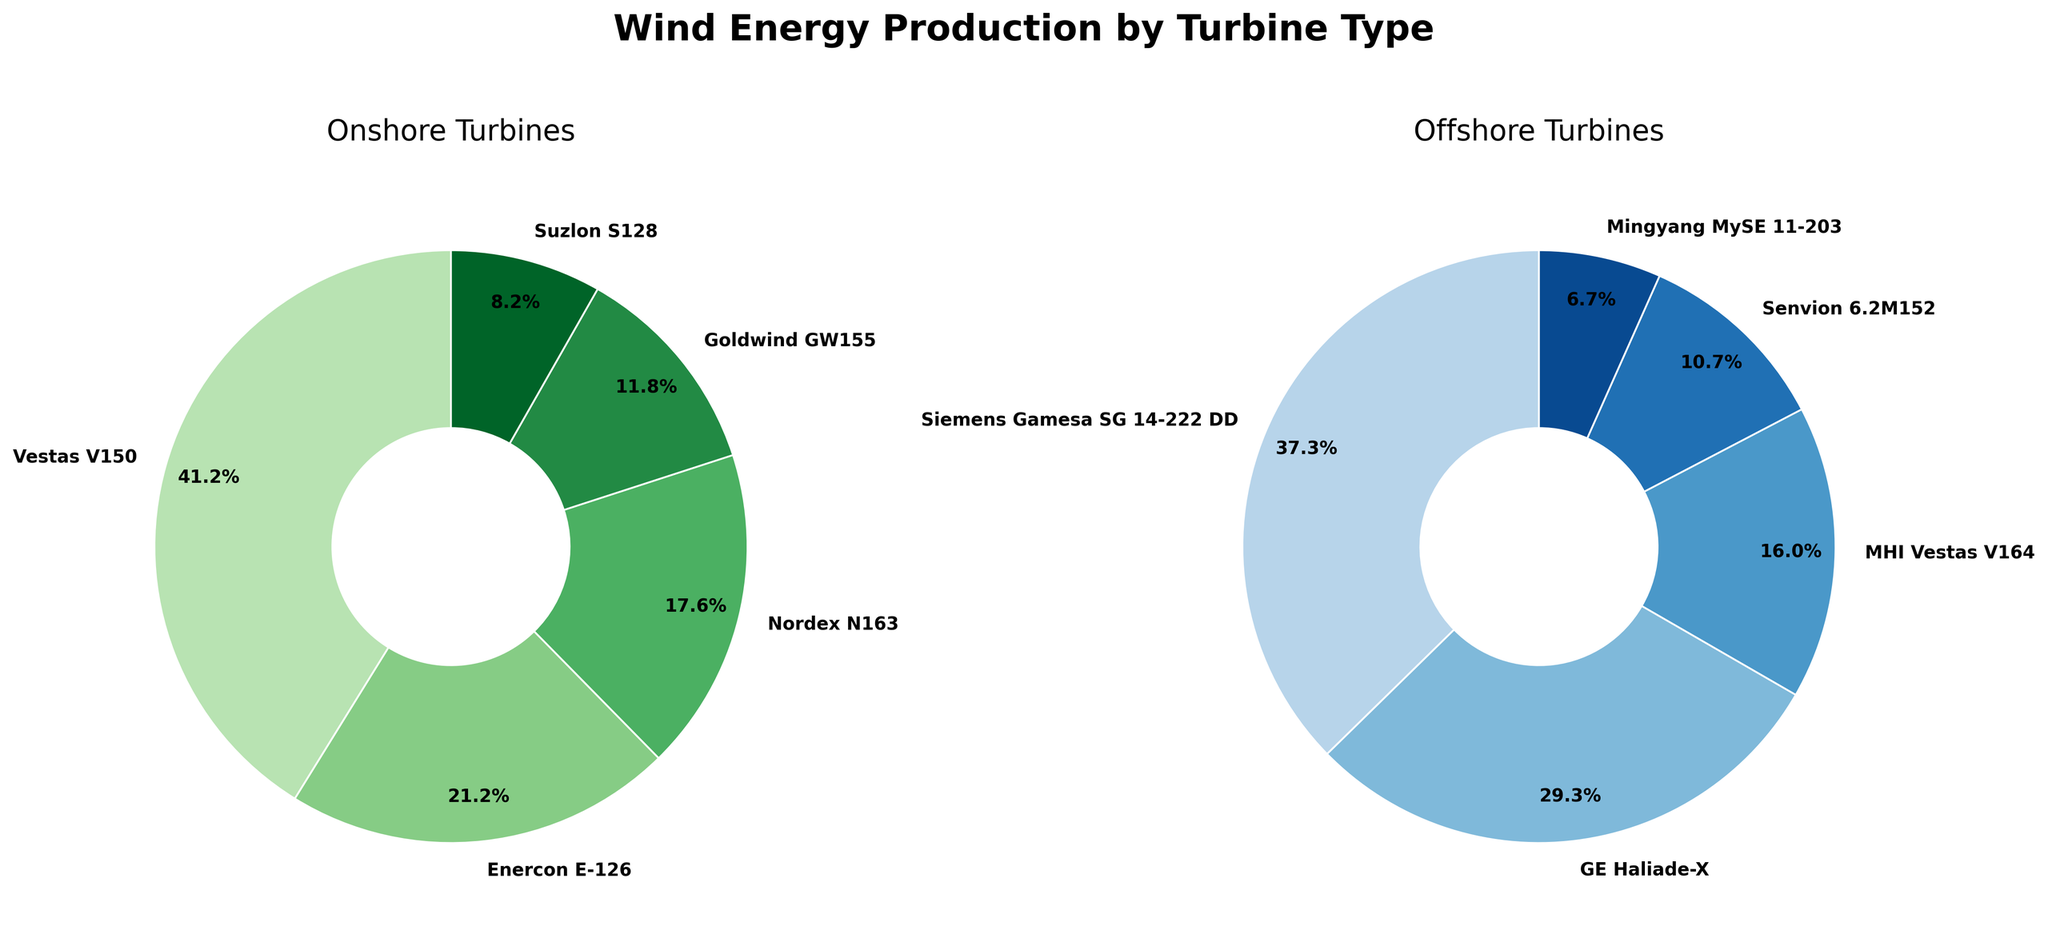Which turbine type contributes the most to onshore wind energy production? By looking at the largest slice of the onshore pie chart, we see that the "Vestas V150" has the largest percentage.
Answer: Vestas V150 What percentage of onshore wind energy production does the Enercon E-126 contribute? In the onshore pie chart, locate the label "Enercon E-126" and read the percentage displayed next to it.
Answer: 18.0% How do the contributions of GE Haliade-X and Siemens Gamesa SG 14-222 DD compare in offshore wind energy production? Check the offshore pie chart for the segments labeled "GE Haliade-X" and "Siemens Gamesa SG 14-222 DD" and compare their percentages. GE Haliade-X has 22% and Siemens Gamesa SG 14-222 DD has 28%.
Answer: Siemens Gamesa SG 14-222 DD produces more What's the combined production percentage of Nordex N163 and Goldwind GW155 in onshore wind energy? In the onshore pie chart, find the percentages for "Nordex N163" and "Goldwind GW155". They are 15% and 10%, respectively. Add these two percentages together: 15% + 10% = 25%.
Answer: 25.0% Which turbine type has the smallest contribution to offshore wind energy production? Look for the smallest slice in the offshore pie chart. The "Mingyang MySE 11-203" slice is the smallest.
Answer: Mingyang MySE 11-203 Is there any overlap between turbine types used for onshore and offshore wind energy production? By checking both pie charts, observe if the same turbine types appear in both charts. There are no labels common to both charts.
Answer: No What is the production difference between the largest contributing turbine types in onshore and offshore wind energy? The largest contributing turbine types are "Vestas V150" with 35% for onshore and "Siemens Gamesa SG 14-222 DD" with 28% for offshore. The difference is 35% - 28% = 7%.
Answer: 7% What proportion of the total offshore wind energy production is from MHI Vestas V164 and Senvion 6.2M152 combined? Find the percentages for "MHI Vestas V164" and "Senvion 6.2M152" in the offshore pie chart, which are 12% and 8% respectively. Sum these values: 12% + 8% = 20%.
Answer: 20% How does the contribution of Suzlon S128 compare to Enercon E-126 in onshore wind energy? Suzlon S128 has a contribution of 7%, while Enercon E-126 has 18%. Comparing the two, Enercon E-126 contributes more than Suzlon S128 (18% > 7%).
Answer: Enercon E-126 contributes more Based on the charts, how many turbine types are dedicated to offshore wind energy? Count the segments in the offshore pie chart. There are six different segments labeled in the offshore pie chart.
Answer: 6 